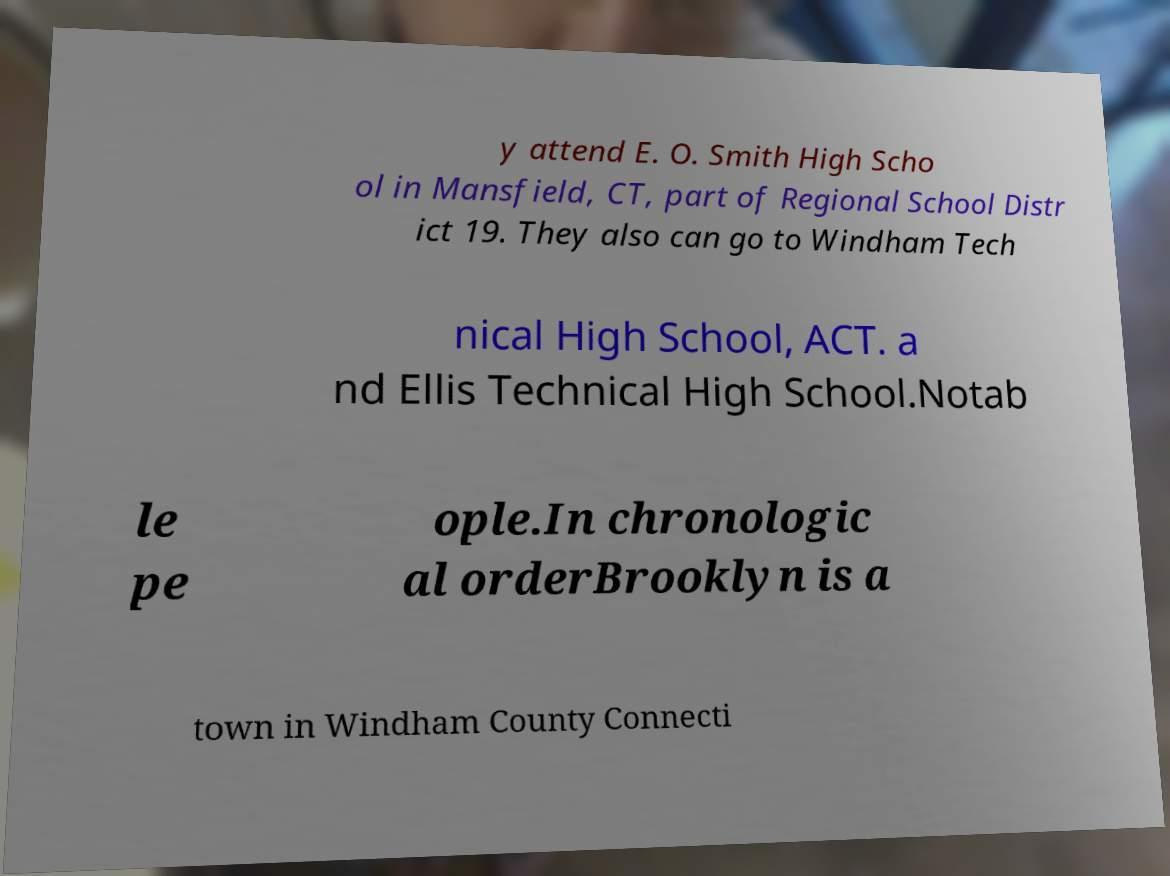I need the written content from this picture converted into text. Can you do that? y attend E. O. Smith High Scho ol in Mansfield, CT, part of Regional School Distr ict 19. They also can go to Windham Tech nical High School, ACT. a nd Ellis Technical High School.Notab le pe ople.In chronologic al orderBrooklyn is a town in Windham County Connecti 